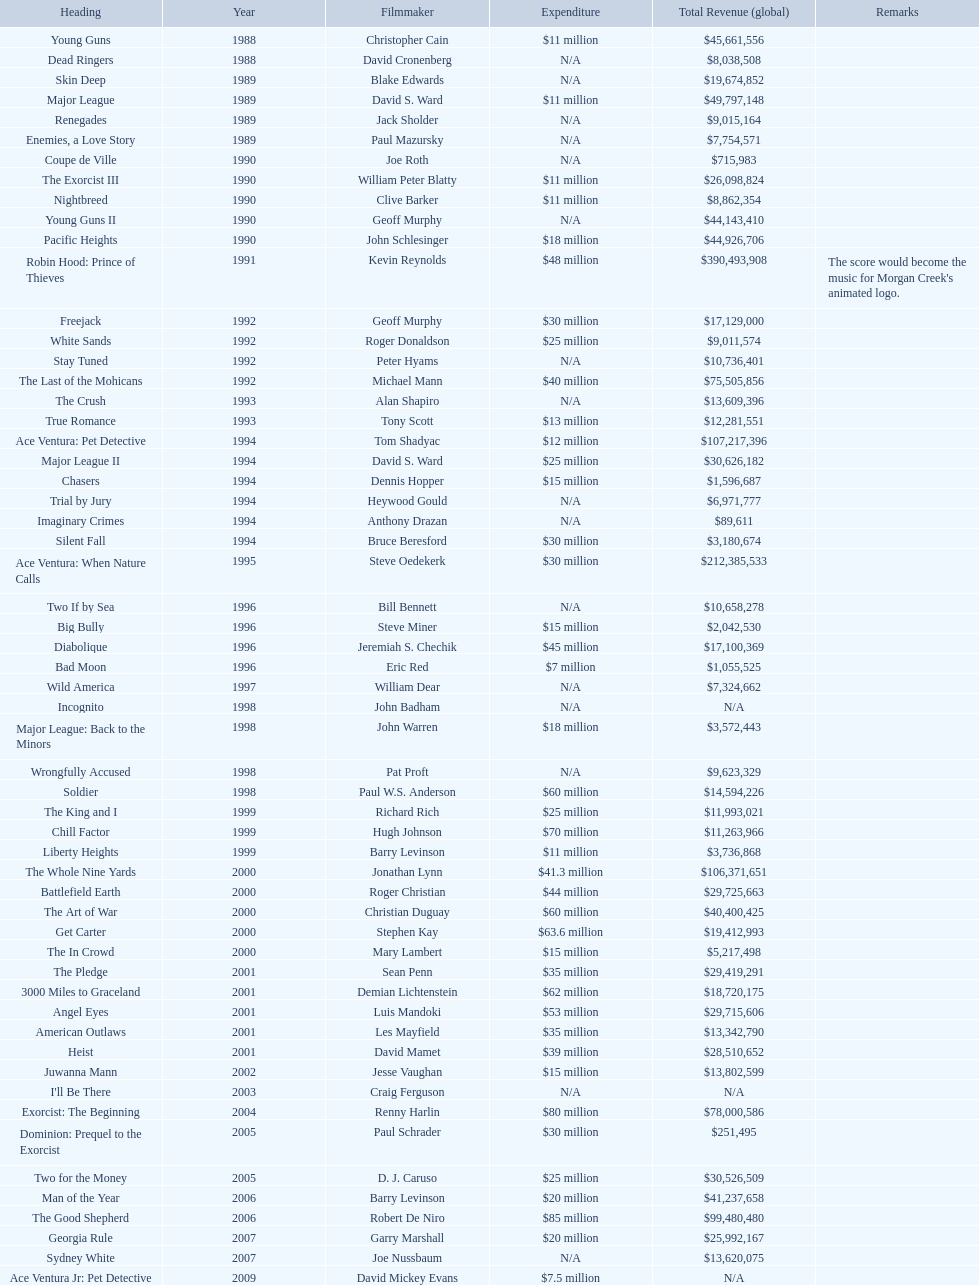Did true romance make more or less money than diabolique? Less. Would you mind parsing the complete table? {'header': ['Heading', 'Year', 'Filmmaker', 'Expenditure', 'Total Revenue (global)', 'Remarks'], 'rows': [['Young Guns', '1988', 'Christopher Cain', '$11 million', '$45,661,556', ''], ['Dead Ringers', '1988', 'David Cronenberg', 'N/A', '$8,038,508', ''], ['Skin Deep', '1989', 'Blake Edwards', 'N/A', '$19,674,852', ''], ['Major League', '1989', 'David S. Ward', '$11 million', '$49,797,148', ''], ['Renegades', '1989', 'Jack Sholder', 'N/A', '$9,015,164', ''], ['Enemies, a Love Story', '1989', 'Paul Mazursky', 'N/A', '$7,754,571', ''], ['Coupe de Ville', '1990', 'Joe Roth', 'N/A', '$715,983', ''], ['The Exorcist III', '1990', 'William Peter Blatty', '$11 million', '$26,098,824', ''], ['Nightbreed', '1990', 'Clive Barker', '$11 million', '$8,862,354', ''], ['Young Guns II', '1990', 'Geoff Murphy', 'N/A', '$44,143,410', ''], ['Pacific Heights', '1990', 'John Schlesinger', '$18 million', '$44,926,706', ''], ['Robin Hood: Prince of Thieves', '1991', 'Kevin Reynolds', '$48 million', '$390,493,908', "The score would become the music for Morgan Creek's animated logo."], ['Freejack', '1992', 'Geoff Murphy', '$30 million', '$17,129,000', ''], ['White Sands', '1992', 'Roger Donaldson', '$25 million', '$9,011,574', ''], ['Stay Tuned', '1992', 'Peter Hyams', 'N/A', '$10,736,401', ''], ['The Last of the Mohicans', '1992', 'Michael Mann', '$40 million', '$75,505,856', ''], ['The Crush', '1993', 'Alan Shapiro', 'N/A', '$13,609,396', ''], ['True Romance', '1993', 'Tony Scott', '$13 million', '$12,281,551', ''], ['Ace Ventura: Pet Detective', '1994', 'Tom Shadyac', '$12 million', '$107,217,396', ''], ['Major League II', '1994', 'David S. Ward', '$25 million', '$30,626,182', ''], ['Chasers', '1994', 'Dennis Hopper', '$15 million', '$1,596,687', ''], ['Trial by Jury', '1994', 'Heywood Gould', 'N/A', '$6,971,777', ''], ['Imaginary Crimes', '1994', 'Anthony Drazan', 'N/A', '$89,611', ''], ['Silent Fall', '1994', 'Bruce Beresford', '$30 million', '$3,180,674', ''], ['Ace Ventura: When Nature Calls', '1995', 'Steve Oedekerk', '$30 million', '$212,385,533', ''], ['Two If by Sea', '1996', 'Bill Bennett', 'N/A', '$10,658,278', ''], ['Big Bully', '1996', 'Steve Miner', '$15 million', '$2,042,530', ''], ['Diabolique', '1996', 'Jeremiah S. Chechik', '$45 million', '$17,100,369', ''], ['Bad Moon', '1996', 'Eric Red', '$7 million', '$1,055,525', ''], ['Wild America', '1997', 'William Dear', 'N/A', '$7,324,662', ''], ['Incognito', '1998', 'John Badham', 'N/A', 'N/A', ''], ['Major League: Back to the Minors', '1998', 'John Warren', '$18 million', '$3,572,443', ''], ['Wrongfully Accused', '1998', 'Pat Proft', 'N/A', '$9,623,329', ''], ['Soldier', '1998', 'Paul W.S. Anderson', '$60 million', '$14,594,226', ''], ['The King and I', '1999', 'Richard Rich', '$25 million', '$11,993,021', ''], ['Chill Factor', '1999', 'Hugh Johnson', '$70 million', '$11,263,966', ''], ['Liberty Heights', '1999', 'Barry Levinson', '$11 million', '$3,736,868', ''], ['The Whole Nine Yards', '2000', 'Jonathan Lynn', '$41.3 million', '$106,371,651', ''], ['Battlefield Earth', '2000', 'Roger Christian', '$44 million', '$29,725,663', ''], ['The Art of War', '2000', 'Christian Duguay', '$60 million', '$40,400,425', ''], ['Get Carter', '2000', 'Stephen Kay', '$63.6 million', '$19,412,993', ''], ['The In Crowd', '2000', 'Mary Lambert', '$15 million', '$5,217,498', ''], ['The Pledge', '2001', 'Sean Penn', '$35 million', '$29,419,291', ''], ['3000 Miles to Graceland', '2001', 'Demian Lichtenstein', '$62 million', '$18,720,175', ''], ['Angel Eyes', '2001', 'Luis Mandoki', '$53 million', '$29,715,606', ''], ['American Outlaws', '2001', 'Les Mayfield', '$35 million', '$13,342,790', ''], ['Heist', '2001', 'David Mamet', '$39 million', '$28,510,652', ''], ['Juwanna Mann', '2002', 'Jesse Vaughan', '$15 million', '$13,802,599', ''], ["I'll Be There", '2003', 'Craig Ferguson', 'N/A', 'N/A', ''], ['Exorcist: The Beginning', '2004', 'Renny Harlin', '$80 million', '$78,000,586', ''], ['Dominion: Prequel to the Exorcist', '2005', 'Paul Schrader', '$30 million', '$251,495', ''], ['Two for the Money', '2005', 'D. J. Caruso', '$25 million', '$30,526,509', ''], ['Man of the Year', '2006', 'Barry Levinson', '$20 million', '$41,237,658', ''], ['The Good Shepherd', '2006', 'Robert De Niro', '$85 million', '$99,480,480', ''], ['Georgia Rule', '2007', 'Garry Marshall', '$20 million', '$25,992,167', ''], ['Sydney White', '2007', 'Joe Nussbaum', 'N/A', '$13,620,075', ''], ['Ace Ventura Jr: Pet Detective', '2009', 'David Mickey Evans', '$7.5 million', 'N/A', ''], ['Dream House', '2011', 'Jim Sheridan', '$50 million', '$38,502,340', ''], ['The Thing', '2011', 'Matthijs van Heijningen Jr.', '$38 million', '$27,428,670', ''], ['Tupac', '2014', 'Antoine Fuqua', '$45 million', '', '']]} 